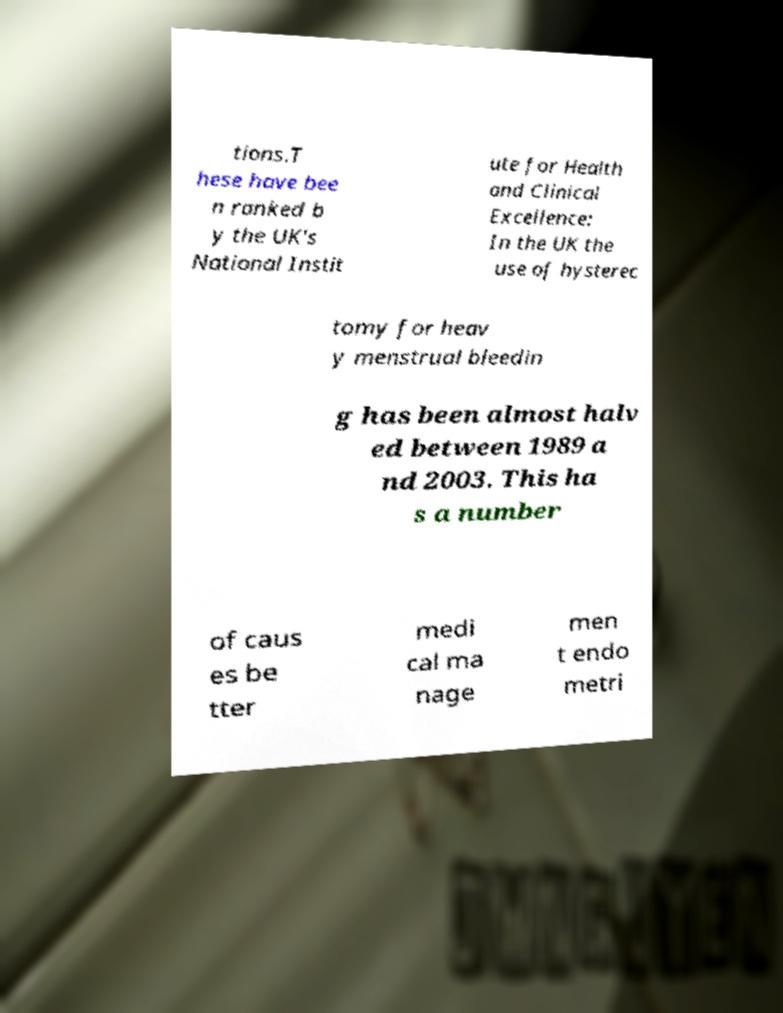What messages or text are displayed in this image? I need them in a readable, typed format. tions.T hese have bee n ranked b y the UK's National Instit ute for Health and Clinical Excellence: In the UK the use of hysterec tomy for heav y menstrual bleedin g has been almost halv ed between 1989 a nd 2003. This ha s a number of caus es be tter medi cal ma nage men t endo metri 